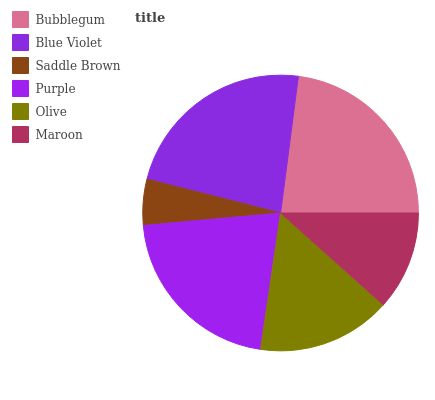Is Saddle Brown the minimum?
Answer yes or no. Yes. Is Blue Violet the maximum?
Answer yes or no. Yes. Is Blue Violet the minimum?
Answer yes or no. No. Is Saddle Brown the maximum?
Answer yes or no. No. Is Blue Violet greater than Saddle Brown?
Answer yes or no. Yes. Is Saddle Brown less than Blue Violet?
Answer yes or no. Yes. Is Saddle Brown greater than Blue Violet?
Answer yes or no. No. Is Blue Violet less than Saddle Brown?
Answer yes or no. No. Is Purple the high median?
Answer yes or no. Yes. Is Olive the low median?
Answer yes or no. Yes. Is Olive the high median?
Answer yes or no. No. Is Bubblegum the low median?
Answer yes or no. No. 